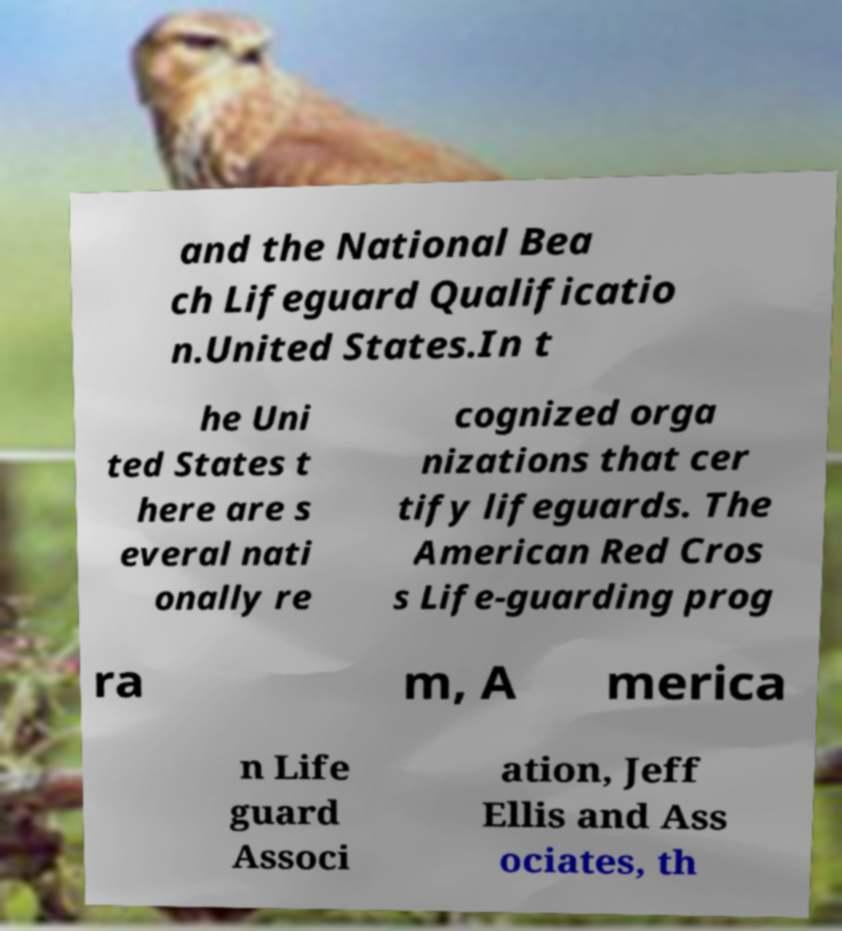Could you assist in decoding the text presented in this image and type it out clearly? and the National Bea ch Lifeguard Qualificatio n.United States.In t he Uni ted States t here are s everal nati onally re cognized orga nizations that cer tify lifeguards. The American Red Cros s Life-guarding prog ra m, A merica n Life guard Associ ation, Jeff Ellis and Ass ociates, th 